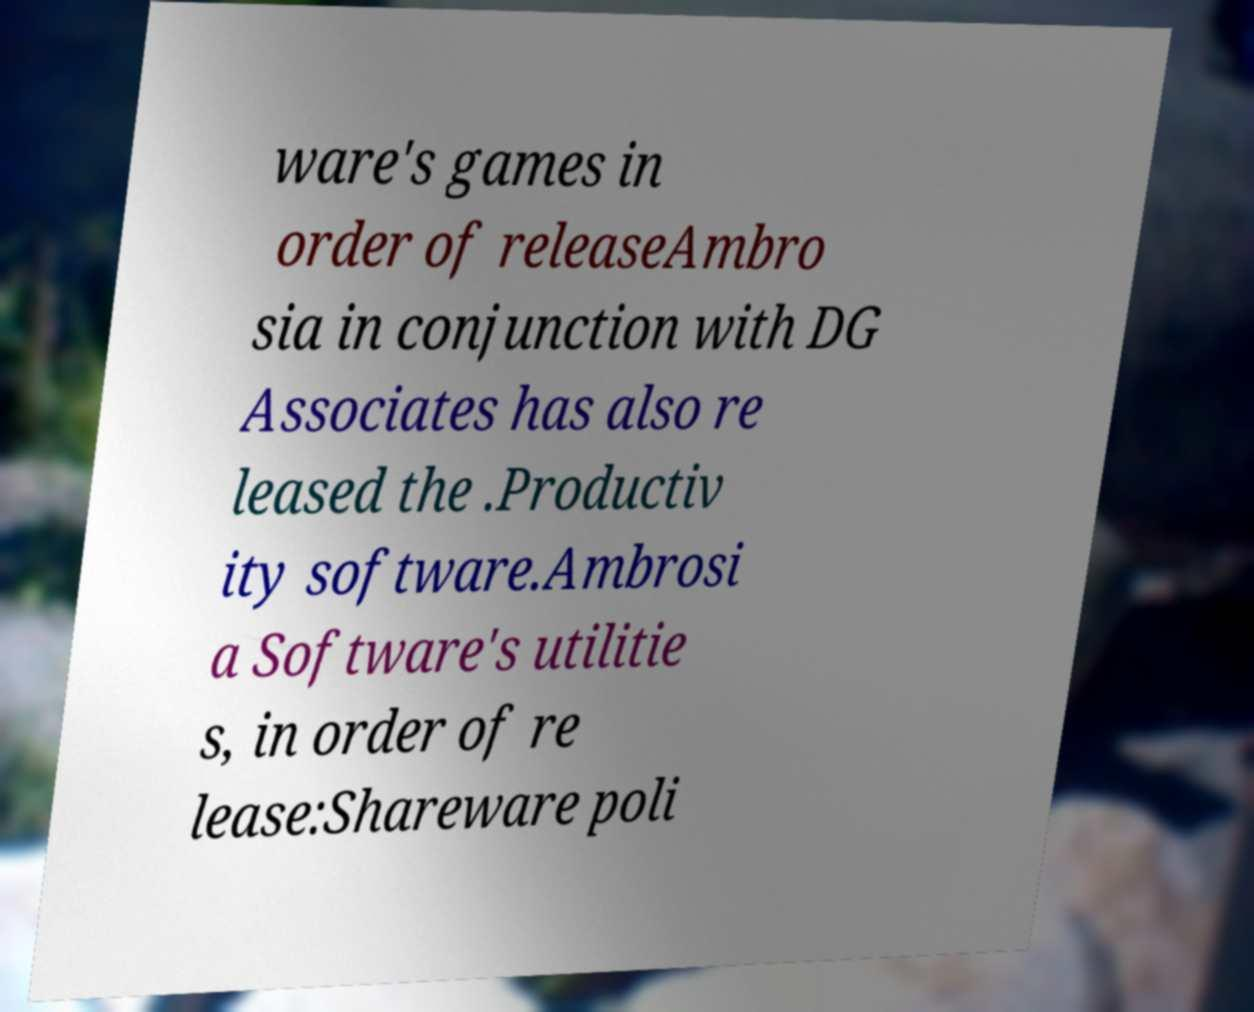For documentation purposes, I need the text within this image transcribed. Could you provide that? ware's games in order of releaseAmbro sia in conjunction with DG Associates has also re leased the .Productiv ity software.Ambrosi a Software's utilitie s, in order of re lease:Shareware poli 